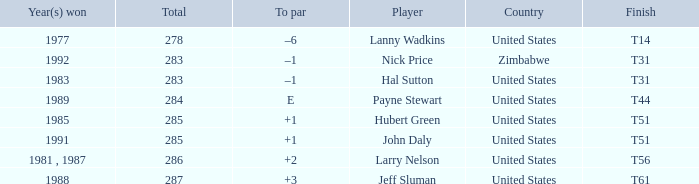What is Country, when Total is greater than 283, and when Year(s) Won is "1989"? United States. 